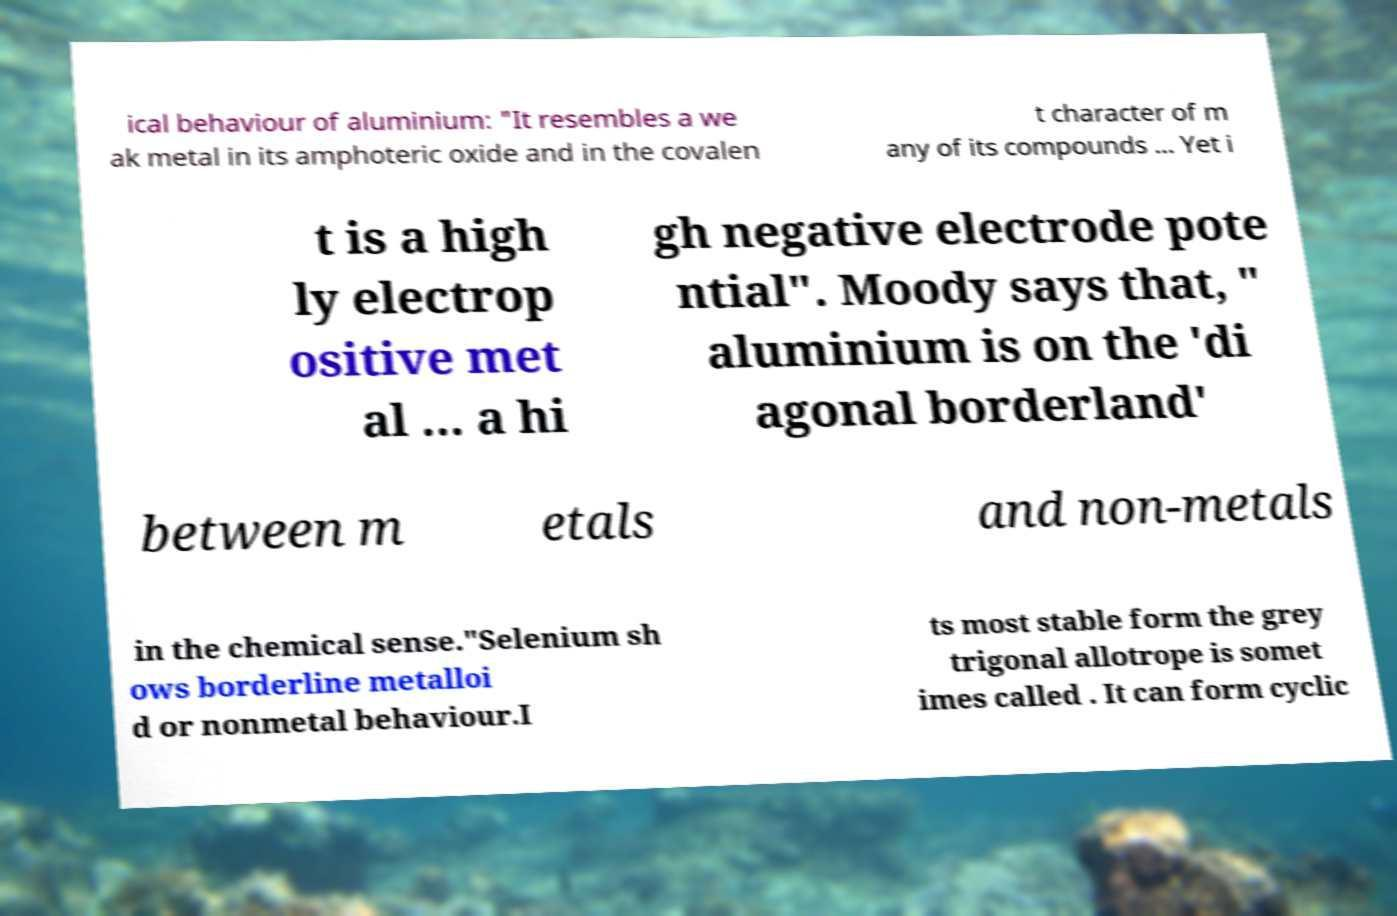Please read and relay the text visible in this image. What does it say? ical behaviour of aluminium: "It resembles a we ak metal in its amphoteric oxide and in the covalen t character of m any of its compounds ... Yet i t is a high ly electrop ositive met al ... a hi gh negative electrode pote ntial". Moody says that, " aluminium is on the 'di agonal borderland' between m etals and non-metals in the chemical sense."Selenium sh ows borderline metalloi d or nonmetal behaviour.I ts most stable form the grey trigonal allotrope is somet imes called . It can form cyclic 